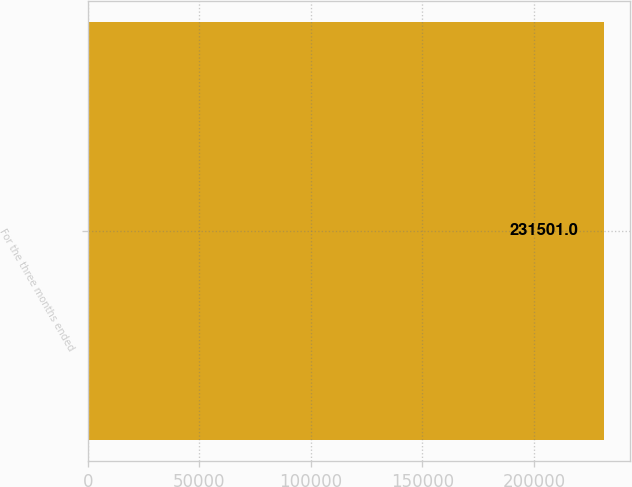Convert chart to OTSL. <chart><loc_0><loc_0><loc_500><loc_500><bar_chart><fcel>For the three months ended<nl><fcel>231501<nl></chart> 